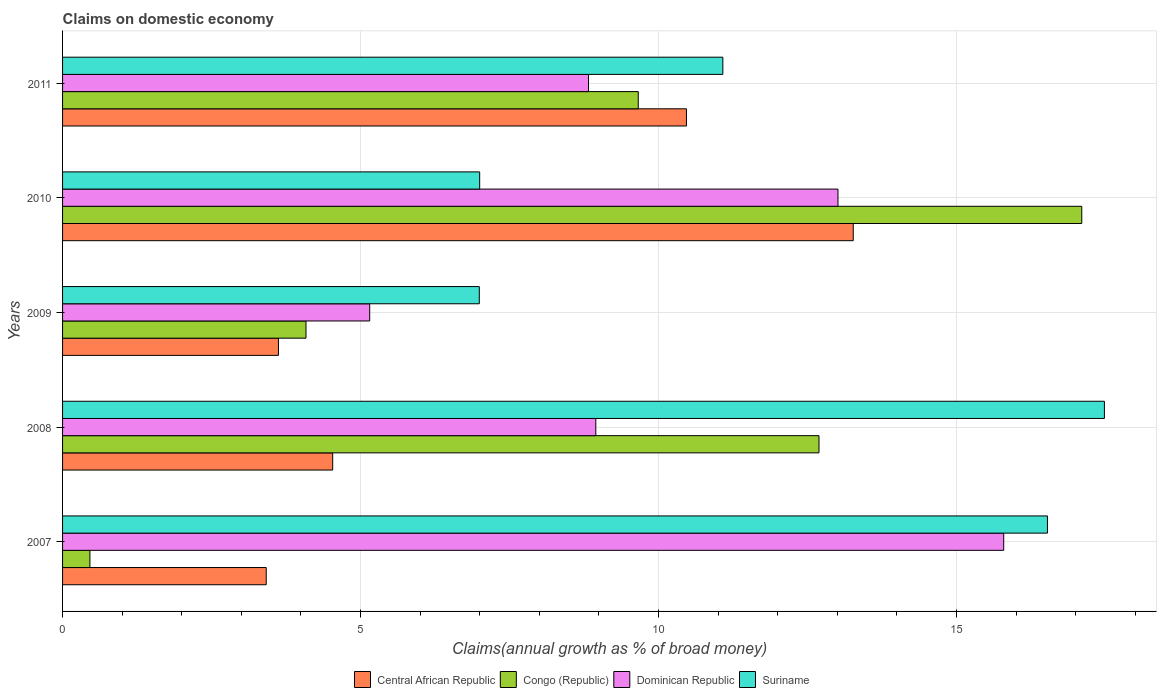How many groups of bars are there?
Offer a terse response. 5. What is the label of the 5th group of bars from the top?
Provide a short and direct response. 2007. What is the percentage of broad money claimed on domestic economy in Congo (Republic) in 2010?
Your answer should be compact. 17.1. Across all years, what is the maximum percentage of broad money claimed on domestic economy in Congo (Republic)?
Provide a succinct answer. 17.1. Across all years, what is the minimum percentage of broad money claimed on domestic economy in Congo (Republic)?
Provide a succinct answer. 0.46. In which year was the percentage of broad money claimed on domestic economy in Dominican Republic maximum?
Offer a very short reply. 2007. What is the total percentage of broad money claimed on domestic economy in Suriname in the graph?
Keep it short and to the point. 59.08. What is the difference between the percentage of broad money claimed on domestic economy in Central African Republic in 2007 and that in 2008?
Keep it short and to the point. -1.11. What is the difference between the percentage of broad money claimed on domestic economy in Suriname in 2009 and the percentage of broad money claimed on domestic economy in Dominican Republic in 2011?
Give a very brief answer. -1.83. What is the average percentage of broad money claimed on domestic economy in Congo (Republic) per year?
Keep it short and to the point. 8.8. In the year 2009, what is the difference between the percentage of broad money claimed on domestic economy in Central African Republic and percentage of broad money claimed on domestic economy in Suriname?
Offer a very short reply. -3.37. What is the ratio of the percentage of broad money claimed on domestic economy in Dominican Republic in 2008 to that in 2009?
Offer a very short reply. 1.74. Is the difference between the percentage of broad money claimed on domestic economy in Central African Republic in 2009 and 2010 greater than the difference between the percentage of broad money claimed on domestic economy in Suriname in 2009 and 2010?
Your answer should be compact. No. What is the difference between the highest and the second highest percentage of broad money claimed on domestic economy in Central African Republic?
Your answer should be very brief. 2.8. What is the difference between the highest and the lowest percentage of broad money claimed on domestic economy in Central African Republic?
Provide a short and direct response. 9.85. Is the sum of the percentage of broad money claimed on domestic economy in Congo (Republic) in 2007 and 2010 greater than the maximum percentage of broad money claimed on domestic economy in Suriname across all years?
Provide a short and direct response. Yes. Is it the case that in every year, the sum of the percentage of broad money claimed on domestic economy in Congo (Republic) and percentage of broad money claimed on domestic economy in Dominican Republic is greater than the sum of percentage of broad money claimed on domestic economy in Central African Republic and percentage of broad money claimed on domestic economy in Suriname?
Provide a succinct answer. No. What does the 2nd bar from the top in 2007 represents?
Your response must be concise. Dominican Republic. What does the 1st bar from the bottom in 2008 represents?
Offer a terse response. Central African Republic. Are all the bars in the graph horizontal?
Provide a short and direct response. Yes. How many years are there in the graph?
Your response must be concise. 5. What is the difference between two consecutive major ticks on the X-axis?
Make the answer very short. 5. Are the values on the major ticks of X-axis written in scientific E-notation?
Your answer should be compact. No. Does the graph contain grids?
Keep it short and to the point. Yes. How are the legend labels stacked?
Your response must be concise. Horizontal. What is the title of the graph?
Your answer should be compact. Claims on domestic economy. Does "Lao PDR" appear as one of the legend labels in the graph?
Ensure brevity in your answer.  No. What is the label or title of the X-axis?
Make the answer very short. Claims(annual growth as % of broad money). What is the label or title of the Y-axis?
Give a very brief answer. Years. What is the Claims(annual growth as % of broad money) of Central African Republic in 2007?
Provide a short and direct response. 3.42. What is the Claims(annual growth as % of broad money) in Congo (Republic) in 2007?
Keep it short and to the point. 0.46. What is the Claims(annual growth as % of broad money) of Dominican Republic in 2007?
Offer a terse response. 15.79. What is the Claims(annual growth as % of broad money) of Suriname in 2007?
Your response must be concise. 16.53. What is the Claims(annual growth as % of broad money) of Central African Republic in 2008?
Ensure brevity in your answer.  4.53. What is the Claims(annual growth as % of broad money) in Congo (Republic) in 2008?
Provide a short and direct response. 12.69. What is the Claims(annual growth as % of broad money) in Dominican Republic in 2008?
Make the answer very short. 8.95. What is the Claims(annual growth as % of broad money) in Suriname in 2008?
Offer a terse response. 17.48. What is the Claims(annual growth as % of broad money) of Central African Republic in 2009?
Ensure brevity in your answer.  3.62. What is the Claims(annual growth as % of broad money) of Congo (Republic) in 2009?
Offer a terse response. 4.08. What is the Claims(annual growth as % of broad money) of Dominican Republic in 2009?
Offer a very short reply. 5.15. What is the Claims(annual growth as % of broad money) in Suriname in 2009?
Your answer should be very brief. 6.99. What is the Claims(annual growth as % of broad money) of Central African Republic in 2010?
Offer a very short reply. 13.27. What is the Claims(annual growth as % of broad money) of Congo (Republic) in 2010?
Ensure brevity in your answer.  17.1. What is the Claims(annual growth as % of broad money) of Dominican Republic in 2010?
Provide a short and direct response. 13.01. What is the Claims(annual growth as % of broad money) of Suriname in 2010?
Ensure brevity in your answer.  7. What is the Claims(annual growth as % of broad money) in Central African Republic in 2011?
Make the answer very short. 10.47. What is the Claims(annual growth as % of broad money) of Congo (Republic) in 2011?
Offer a terse response. 9.66. What is the Claims(annual growth as % of broad money) in Dominican Republic in 2011?
Give a very brief answer. 8.83. What is the Claims(annual growth as % of broad money) in Suriname in 2011?
Ensure brevity in your answer.  11.08. Across all years, what is the maximum Claims(annual growth as % of broad money) in Central African Republic?
Provide a succinct answer. 13.27. Across all years, what is the maximum Claims(annual growth as % of broad money) of Congo (Republic)?
Give a very brief answer. 17.1. Across all years, what is the maximum Claims(annual growth as % of broad money) in Dominican Republic?
Your response must be concise. 15.79. Across all years, what is the maximum Claims(annual growth as % of broad money) of Suriname?
Provide a succinct answer. 17.48. Across all years, what is the minimum Claims(annual growth as % of broad money) of Central African Republic?
Your answer should be compact. 3.42. Across all years, what is the minimum Claims(annual growth as % of broad money) of Congo (Republic)?
Ensure brevity in your answer.  0.46. Across all years, what is the minimum Claims(annual growth as % of broad money) in Dominican Republic?
Provide a short and direct response. 5.15. Across all years, what is the minimum Claims(annual growth as % of broad money) in Suriname?
Keep it short and to the point. 6.99. What is the total Claims(annual growth as % of broad money) in Central African Republic in the graph?
Offer a very short reply. 35.31. What is the total Claims(annual growth as % of broad money) in Congo (Republic) in the graph?
Your answer should be very brief. 44. What is the total Claims(annual growth as % of broad money) of Dominican Republic in the graph?
Offer a very short reply. 51.73. What is the total Claims(annual growth as % of broad money) of Suriname in the graph?
Your response must be concise. 59.08. What is the difference between the Claims(annual growth as % of broad money) in Central African Republic in 2007 and that in 2008?
Ensure brevity in your answer.  -1.11. What is the difference between the Claims(annual growth as % of broad money) in Congo (Republic) in 2007 and that in 2008?
Your answer should be very brief. -12.23. What is the difference between the Claims(annual growth as % of broad money) of Dominican Republic in 2007 and that in 2008?
Ensure brevity in your answer.  6.84. What is the difference between the Claims(annual growth as % of broad money) of Suriname in 2007 and that in 2008?
Keep it short and to the point. -0.96. What is the difference between the Claims(annual growth as % of broad money) in Central African Republic in 2007 and that in 2009?
Your response must be concise. -0.21. What is the difference between the Claims(annual growth as % of broad money) of Congo (Republic) in 2007 and that in 2009?
Your response must be concise. -3.63. What is the difference between the Claims(annual growth as % of broad money) in Dominican Republic in 2007 and that in 2009?
Provide a succinct answer. 10.64. What is the difference between the Claims(annual growth as % of broad money) of Suriname in 2007 and that in 2009?
Make the answer very short. 9.53. What is the difference between the Claims(annual growth as % of broad money) in Central African Republic in 2007 and that in 2010?
Keep it short and to the point. -9.85. What is the difference between the Claims(annual growth as % of broad money) in Congo (Republic) in 2007 and that in 2010?
Your answer should be compact. -16.64. What is the difference between the Claims(annual growth as % of broad money) in Dominican Republic in 2007 and that in 2010?
Ensure brevity in your answer.  2.78. What is the difference between the Claims(annual growth as % of broad money) in Suriname in 2007 and that in 2010?
Keep it short and to the point. 9.53. What is the difference between the Claims(annual growth as % of broad money) of Central African Republic in 2007 and that in 2011?
Your answer should be compact. -7.05. What is the difference between the Claims(annual growth as % of broad money) in Congo (Republic) in 2007 and that in 2011?
Your response must be concise. -9.2. What is the difference between the Claims(annual growth as % of broad money) of Dominican Republic in 2007 and that in 2011?
Offer a terse response. 6.97. What is the difference between the Claims(annual growth as % of broad money) of Suriname in 2007 and that in 2011?
Provide a short and direct response. 5.45. What is the difference between the Claims(annual growth as % of broad money) of Central African Republic in 2008 and that in 2009?
Make the answer very short. 0.91. What is the difference between the Claims(annual growth as % of broad money) in Congo (Republic) in 2008 and that in 2009?
Provide a succinct answer. 8.61. What is the difference between the Claims(annual growth as % of broad money) in Dominican Republic in 2008 and that in 2009?
Offer a very short reply. 3.79. What is the difference between the Claims(annual growth as % of broad money) in Suriname in 2008 and that in 2009?
Provide a short and direct response. 10.49. What is the difference between the Claims(annual growth as % of broad money) of Central African Republic in 2008 and that in 2010?
Ensure brevity in your answer.  -8.73. What is the difference between the Claims(annual growth as % of broad money) of Congo (Republic) in 2008 and that in 2010?
Provide a short and direct response. -4.41. What is the difference between the Claims(annual growth as % of broad money) of Dominican Republic in 2008 and that in 2010?
Offer a terse response. -4.06. What is the difference between the Claims(annual growth as % of broad money) in Suriname in 2008 and that in 2010?
Provide a short and direct response. 10.48. What is the difference between the Claims(annual growth as % of broad money) of Central African Republic in 2008 and that in 2011?
Provide a short and direct response. -5.94. What is the difference between the Claims(annual growth as % of broad money) in Congo (Republic) in 2008 and that in 2011?
Your answer should be compact. 3.03. What is the difference between the Claims(annual growth as % of broad money) of Dominican Republic in 2008 and that in 2011?
Provide a succinct answer. 0.12. What is the difference between the Claims(annual growth as % of broad money) in Suriname in 2008 and that in 2011?
Your answer should be compact. 6.4. What is the difference between the Claims(annual growth as % of broad money) in Central African Republic in 2009 and that in 2010?
Provide a short and direct response. -9.64. What is the difference between the Claims(annual growth as % of broad money) in Congo (Republic) in 2009 and that in 2010?
Provide a succinct answer. -13.02. What is the difference between the Claims(annual growth as % of broad money) in Dominican Republic in 2009 and that in 2010?
Your answer should be compact. -7.86. What is the difference between the Claims(annual growth as % of broad money) of Suriname in 2009 and that in 2010?
Make the answer very short. -0.01. What is the difference between the Claims(annual growth as % of broad money) of Central African Republic in 2009 and that in 2011?
Offer a terse response. -6.85. What is the difference between the Claims(annual growth as % of broad money) of Congo (Republic) in 2009 and that in 2011?
Make the answer very short. -5.58. What is the difference between the Claims(annual growth as % of broad money) in Dominican Republic in 2009 and that in 2011?
Provide a succinct answer. -3.67. What is the difference between the Claims(annual growth as % of broad money) in Suriname in 2009 and that in 2011?
Make the answer very short. -4.09. What is the difference between the Claims(annual growth as % of broad money) of Central African Republic in 2010 and that in 2011?
Give a very brief answer. 2.8. What is the difference between the Claims(annual growth as % of broad money) of Congo (Republic) in 2010 and that in 2011?
Your response must be concise. 7.44. What is the difference between the Claims(annual growth as % of broad money) in Dominican Republic in 2010 and that in 2011?
Your response must be concise. 4.19. What is the difference between the Claims(annual growth as % of broad money) of Suriname in 2010 and that in 2011?
Make the answer very short. -4.08. What is the difference between the Claims(annual growth as % of broad money) of Central African Republic in 2007 and the Claims(annual growth as % of broad money) of Congo (Republic) in 2008?
Your answer should be very brief. -9.28. What is the difference between the Claims(annual growth as % of broad money) of Central African Republic in 2007 and the Claims(annual growth as % of broad money) of Dominican Republic in 2008?
Your answer should be very brief. -5.53. What is the difference between the Claims(annual growth as % of broad money) in Central African Republic in 2007 and the Claims(annual growth as % of broad money) in Suriname in 2008?
Give a very brief answer. -14.06. What is the difference between the Claims(annual growth as % of broad money) in Congo (Republic) in 2007 and the Claims(annual growth as % of broad money) in Dominican Republic in 2008?
Provide a short and direct response. -8.49. What is the difference between the Claims(annual growth as % of broad money) in Congo (Republic) in 2007 and the Claims(annual growth as % of broad money) in Suriname in 2008?
Your answer should be compact. -17.02. What is the difference between the Claims(annual growth as % of broad money) in Dominican Republic in 2007 and the Claims(annual growth as % of broad money) in Suriname in 2008?
Make the answer very short. -1.69. What is the difference between the Claims(annual growth as % of broad money) in Central African Republic in 2007 and the Claims(annual growth as % of broad money) in Congo (Republic) in 2009?
Provide a short and direct response. -0.67. What is the difference between the Claims(annual growth as % of broad money) of Central African Republic in 2007 and the Claims(annual growth as % of broad money) of Dominican Republic in 2009?
Your response must be concise. -1.74. What is the difference between the Claims(annual growth as % of broad money) of Central African Republic in 2007 and the Claims(annual growth as % of broad money) of Suriname in 2009?
Your answer should be compact. -3.57. What is the difference between the Claims(annual growth as % of broad money) in Congo (Republic) in 2007 and the Claims(annual growth as % of broad money) in Dominican Republic in 2009?
Give a very brief answer. -4.69. What is the difference between the Claims(annual growth as % of broad money) of Congo (Republic) in 2007 and the Claims(annual growth as % of broad money) of Suriname in 2009?
Offer a terse response. -6.53. What is the difference between the Claims(annual growth as % of broad money) in Dominican Republic in 2007 and the Claims(annual growth as % of broad money) in Suriname in 2009?
Provide a short and direct response. 8.8. What is the difference between the Claims(annual growth as % of broad money) of Central African Republic in 2007 and the Claims(annual growth as % of broad money) of Congo (Republic) in 2010?
Offer a very short reply. -13.68. What is the difference between the Claims(annual growth as % of broad money) of Central African Republic in 2007 and the Claims(annual growth as % of broad money) of Dominican Republic in 2010?
Your answer should be very brief. -9.59. What is the difference between the Claims(annual growth as % of broad money) of Central African Republic in 2007 and the Claims(annual growth as % of broad money) of Suriname in 2010?
Your answer should be compact. -3.58. What is the difference between the Claims(annual growth as % of broad money) in Congo (Republic) in 2007 and the Claims(annual growth as % of broad money) in Dominican Republic in 2010?
Keep it short and to the point. -12.55. What is the difference between the Claims(annual growth as % of broad money) of Congo (Republic) in 2007 and the Claims(annual growth as % of broad money) of Suriname in 2010?
Ensure brevity in your answer.  -6.54. What is the difference between the Claims(annual growth as % of broad money) in Dominican Republic in 2007 and the Claims(annual growth as % of broad money) in Suriname in 2010?
Offer a very short reply. 8.79. What is the difference between the Claims(annual growth as % of broad money) in Central African Republic in 2007 and the Claims(annual growth as % of broad money) in Congo (Republic) in 2011?
Provide a short and direct response. -6.24. What is the difference between the Claims(annual growth as % of broad money) in Central African Republic in 2007 and the Claims(annual growth as % of broad money) in Dominican Republic in 2011?
Your answer should be compact. -5.41. What is the difference between the Claims(annual growth as % of broad money) of Central African Republic in 2007 and the Claims(annual growth as % of broad money) of Suriname in 2011?
Your answer should be very brief. -7.66. What is the difference between the Claims(annual growth as % of broad money) in Congo (Republic) in 2007 and the Claims(annual growth as % of broad money) in Dominican Republic in 2011?
Make the answer very short. -8.37. What is the difference between the Claims(annual growth as % of broad money) in Congo (Republic) in 2007 and the Claims(annual growth as % of broad money) in Suriname in 2011?
Offer a terse response. -10.62. What is the difference between the Claims(annual growth as % of broad money) in Dominican Republic in 2007 and the Claims(annual growth as % of broad money) in Suriname in 2011?
Give a very brief answer. 4.71. What is the difference between the Claims(annual growth as % of broad money) of Central African Republic in 2008 and the Claims(annual growth as % of broad money) of Congo (Republic) in 2009?
Offer a very short reply. 0.45. What is the difference between the Claims(annual growth as % of broad money) of Central African Republic in 2008 and the Claims(annual growth as % of broad money) of Dominican Republic in 2009?
Keep it short and to the point. -0.62. What is the difference between the Claims(annual growth as % of broad money) in Central African Republic in 2008 and the Claims(annual growth as % of broad money) in Suriname in 2009?
Your response must be concise. -2.46. What is the difference between the Claims(annual growth as % of broad money) in Congo (Republic) in 2008 and the Claims(annual growth as % of broad money) in Dominican Republic in 2009?
Offer a very short reply. 7.54. What is the difference between the Claims(annual growth as % of broad money) in Congo (Republic) in 2008 and the Claims(annual growth as % of broad money) in Suriname in 2009?
Your answer should be compact. 5.7. What is the difference between the Claims(annual growth as % of broad money) in Dominican Republic in 2008 and the Claims(annual growth as % of broad money) in Suriname in 2009?
Offer a terse response. 1.96. What is the difference between the Claims(annual growth as % of broad money) of Central African Republic in 2008 and the Claims(annual growth as % of broad money) of Congo (Republic) in 2010?
Offer a very short reply. -12.57. What is the difference between the Claims(annual growth as % of broad money) of Central African Republic in 2008 and the Claims(annual growth as % of broad money) of Dominican Republic in 2010?
Keep it short and to the point. -8.48. What is the difference between the Claims(annual growth as % of broad money) of Central African Republic in 2008 and the Claims(annual growth as % of broad money) of Suriname in 2010?
Offer a terse response. -2.47. What is the difference between the Claims(annual growth as % of broad money) in Congo (Republic) in 2008 and the Claims(annual growth as % of broad money) in Dominican Republic in 2010?
Your answer should be very brief. -0.32. What is the difference between the Claims(annual growth as % of broad money) in Congo (Republic) in 2008 and the Claims(annual growth as % of broad money) in Suriname in 2010?
Offer a terse response. 5.69. What is the difference between the Claims(annual growth as % of broad money) in Dominican Republic in 2008 and the Claims(annual growth as % of broad money) in Suriname in 2010?
Provide a short and direct response. 1.95. What is the difference between the Claims(annual growth as % of broad money) of Central African Republic in 2008 and the Claims(annual growth as % of broad money) of Congo (Republic) in 2011?
Provide a short and direct response. -5.13. What is the difference between the Claims(annual growth as % of broad money) of Central African Republic in 2008 and the Claims(annual growth as % of broad money) of Dominican Republic in 2011?
Ensure brevity in your answer.  -4.29. What is the difference between the Claims(annual growth as % of broad money) of Central African Republic in 2008 and the Claims(annual growth as % of broad money) of Suriname in 2011?
Your answer should be very brief. -6.55. What is the difference between the Claims(annual growth as % of broad money) of Congo (Republic) in 2008 and the Claims(annual growth as % of broad money) of Dominican Republic in 2011?
Keep it short and to the point. 3.87. What is the difference between the Claims(annual growth as % of broad money) of Congo (Republic) in 2008 and the Claims(annual growth as % of broad money) of Suriname in 2011?
Give a very brief answer. 1.61. What is the difference between the Claims(annual growth as % of broad money) of Dominican Republic in 2008 and the Claims(annual growth as % of broad money) of Suriname in 2011?
Give a very brief answer. -2.13. What is the difference between the Claims(annual growth as % of broad money) in Central African Republic in 2009 and the Claims(annual growth as % of broad money) in Congo (Republic) in 2010?
Keep it short and to the point. -13.48. What is the difference between the Claims(annual growth as % of broad money) in Central African Republic in 2009 and the Claims(annual growth as % of broad money) in Dominican Republic in 2010?
Your answer should be very brief. -9.39. What is the difference between the Claims(annual growth as % of broad money) in Central African Republic in 2009 and the Claims(annual growth as % of broad money) in Suriname in 2010?
Make the answer very short. -3.38. What is the difference between the Claims(annual growth as % of broad money) of Congo (Republic) in 2009 and the Claims(annual growth as % of broad money) of Dominican Republic in 2010?
Give a very brief answer. -8.93. What is the difference between the Claims(annual growth as % of broad money) in Congo (Republic) in 2009 and the Claims(annual growth as % of broad money) in Suriname in 2010?
Give a very brief answer. -2.91. What is the difference between the Claims(annual growth as % of broad money) in Dominican Republic in 2009 and the Claims(annual growth as % of broad money) in Suriname in 2010?
Your response must be concise. -1.85. What is the difference between the Claims(annual growth as % of broad money) of Central African Republic in 2009 and the Claims(annual growth as % of broad money) of Congo (Republic) in 2011?
Make the answer very short. -6.04. What is the difference between the Claims(annual growth as % of broad money) in Central African Republic in 2009 and the Claims(annual growth as % of broad money) in Dominican Republic in 2011?
Ensure brevity in your answer.  -5.2. What is the difference between the Claims(annual growth as % of broad money) of Central African Republic in 2009 and the Claims(annual growth as % of broad money) of Suriname in 2011?
Provide a succinct answer. -7.46. What is the difference between the Claims(annual growth as % of broad money) in Congo (Republic) in 2009 and the Claims(annual growth as % of broad money) in Dominican Republic in 2011?
Make the answer very short. -4.74. What is the difference between the Claims(annual growth as % of broad money) of Congo (Republic) in 2009 and the Claims(annual growth as % of broad money) of Suriname in 2011?
Offer a very short reply. -6.99. What is the difference between the Claims(annual growth as % of broad money) in Dominican Republic in 2009 and the Claims(annual growth as % of broad money) in Suriname in 2011?
Keep it short and to the point. -5.93. What is the difference between the Claims(annual growth as % of broad money) of Central African Republic in 2010 and the Claims(annual growth as % of broad money) of Congo (Republic) in 2011?
Your answer should be compact. 3.61. What is the difference between the Claims(annual growth as % of broad money) in Central African Republic in 2010 and the Claims(annual growth as % of broad money) in Dominican Republic in 2011?
Your response must be concise. 4.44. What is the difference between the Claims(annual growth as % of broad money) in Central African Republic in 2010 and the Claims(annual growth as % of broad money) in Suriname in 2011?
Provide a short and direct response. 2.19. What is the difference between the Claims(annual growth as % of broad money) of Congo (Republic) in 2010 and the Claims(annual growth as % of broad money) of Dominican Republic in 2011?
Make the answer very short. 8.28. What is the difference between the Claims(annual growth as % of broad money) in Congo (Republic) in 2010 and the Claims(annual growth as % of broad money) in Suriname in 2011?
Keep it short and to the point. 6.02. What is the difference between the Claims(annual growth as % of broad money) of Dominican Republic in 2010 and the Claims(annual growth as % of broad money) of Suriname in 2011?
Give a very brief answer. 1.93. What is the average Claims(annual growth as % of broad money) of Central African Republic per year?
Keep it short and to the point. 7.06. What is the average Claims(annual growth as % of broad money) of Congo (Republic) per year?
Offer a terse response. 8.8. What is the average Claims(annual growth as % of broad money) of Dominican Republic per year?
Keep it short and to the point. 10.35. What is the average Claims(annual growth as % of broad money) in Suriname per year?
Your answer should be very brief. 11.82. In the year 2007, what is the difference between the Claims(annual growth as % of broad money) in Central African Republic and Claims(annual growth as % of broad money) in Congo (Republic)?
Your answer should be compact. 2.96. In the year 2007, what is the difference between the Claims(annual growth as % of broad money) of Central African Republic and Claims(annual growth as % of broad money) of Dominican Republic?
Ensure brevity in your answer.  -12.37. In the year 2007, what is the difference between the Claims(annual growth as % of broad money) of Central African Republic and Claims(annual growth as % of broad money) of Suriname?
Ensure brevity in your answer.  -13.11. In the year 2007, what is the difference between the Claims(annual growth as % of broad money) of Congo (Republic) and Claims(annual growth as % of broad money) of Dominican Republic?
Offer a very short reply. -15.33. In the year 2007, what is the difference between the Claims(annual growth as % of broad money) of Congo (Republic) and Claims(annual growth as % of broad money) of Suriname?
Your response must be concise. -16.07. In the year 2007, what is the difference between the Claims(annual growth as % of broad money) of Dominican Republic and Claims(annual growth as % of broad money) of Suriname?
Give a very brief answer. -0.73. In the year 2008, what is the difference between the Claims(annual growth as % of broad money) of Central African Republic and Claims(annual growth as % of broad money) of Congo (Republic)?
Offer a very short reply. -8.16. In the year 2008, what is the difference between the Claims(annual growth as % of broad money) in Central African Republic and Claims(annual growth as % of broad money) in Dominican Republic?
Ensure brevity in your answer.  -4.42. In the year 2008, what is the difference between the Claims(annual growth as % of broad money) in Central African Republic and Claims(annual growth as % of broad money) in Suriname?
Your answer should be compact. -12.95. In the year 2008, what is the difference between the Claims(annual growth as % of broad money) of Congo (Republic) and Claims(annual growth as % of broad money) of Dominican Republic?
Your response must be concise. 3.74. In the year 2008, what is the difference between the Claims(annual growth as % of broad money) of Congo (Republic) and Claims(annual growth as % of broad money) of Suriname?
Make the answer very short. -4.79. In the year 2008, what is the difference between the Claims(annual growth as % of broad money) of Dominican Republic and Claims(annual growth as % of broad money) of Suriname?
Make the answer very short. -8.53. In the year 2009, what is the difference between the Claims(annual growth as % of broad money) of Central African Republic and Claims(annual growth as % of broad money) of Congo (Republic)?
Offer a very short reply. -0.46. In the year 2009, what is the difference between the Claims(annual growth as % of broad money) in Central African Republic and Claims(annual growth as % of broad money) in Dominican Republic?
Ensure brevity in your answer.  -1.53. In the year 2009, what is the difference between the Claims(annual growth as % of broad money) of Central African Republic and Claims(annual growth as % of broad money) of Suriname?
Provide a short and direct response. -3.37. In the year 2009, what is the difference between the Claims(annual growth as % of broad money) in Congo (Republic) and Claims(annual growth as % of broad money) in Dominican Republic?
Keep it short and to the point. -1.07. In the year 2009, what is the difference between the Claims(annual growth as % of broad money) of Congo (Republic) and Claims(annual growth as % of broad money) of Suriname?
Offer a very short reply. -2.91. In the year 2009, what is the difference between the Claims(annual growth as % of broad money) in Dominican Republic and Claims(annual growth as % of broad money) in Suriname?
Your answer should be compact. -1.84. In the year 2010, what is the difference between the Claims(annual growth as % of broad money) in Central African Republic and Claims(annual growth as % of broad money) in Congo (Republic)?
Provide a succinct answer. -3.83. In the year 2010, what is the difference between the Claims(annual growth as % of broad money) in Central African Republic and Claims(annual growth as % of broad money) in Dominican Republic?
Your answer should be compact. 0.26. In the year 2010, what is the difference between the Claims(annual growth as % of broad money) of Central African Republic and Claims(annual growth as % of broad money) of Suriname?
Offer a terse response. 6.27. In the year 2010, what is the difference between the Claims(annual growth as % of broad money) in Congo (Republic) and Claims(annual growth as % of broad money) in Dominican Republic?
Give a very brief answer. 4.09. In the year 2010, what is the difference between the Claims(annual growth as % of broad money) in Congo (Republic) and Claims(annual growth as % of broad money) in Suriname?
Provide a succinct answer. 10.1. In the year 2010, what is the difference between the Claims(annual growth as % of broad money) of Dominican Republic and Claims(annual growth as % of broad money) of Suriname?
Ensure brevity in your answer.  6.01. In the year 2011, what is the difference between the Claims(annual growth as % of broad money) in Central African Republic and Claims(annual growth as % of broad money) in Congo (Republic)?
Ensure brevity in your answer.  0.81. In the year 2011, what is the difference between the Claims(annual growth as % of broad money) in Central African Republic and Claims(annual growth as % of broad money) in Dominican Republic?
Provide a short and direct response. 1.64. In the year 2011, what is the difference between the Claims(annual growth as % of broad money) in Central African Republic and Claims(annual growth as % of broad money) in Suriname?
Offer a terse response. -0.61. In the year 2011, what is the difference between the Claims(annual growth as % of broad money) in Congo (Republic) and Claims(annual growth as % of broad money) in Dominican Republic?
Provide a short and direct response. 0.83. In the year 2011, what is the difference between the Claims(annual growth as % of broad money) of Congo (Republic) and Claims(annual growth as % of broad money) of Suriname?
Make the answer very short. -1.42. In the year 2011, what is the difference between the Claims(annual growth as % of broad money) in Dominican Republic and Claims(annual growth as % of broad money) in Suriname?
Provide a short and direct response. -2.25. What is the ratio of the Claims(annual growth as % of broad money) in Central African Republic in 2007 to that in 2008?
Your answer should be compact. 0.75. What is the ratio of the Claims(annual growth as % of broad money) in Congo (Republic) in 2007 to that in 2008?
Your answer should be very brief. 0.04. What is the ratio of the Claims(annual growth as % of broad money) of Dominican Republic in 2007 to that in 2008?
Make the answer very short. 1.76. What is the ratio of the Claims(annual growth as % of broad money) in Suriname in 2007 to that in 2008?
Provide a succinct answer. 0.95. What is the ratio of the Claims(annual growth as % of broad money) of Central African Republic in 2007 to that in 2009?
Ensure brevity in your answer.  0.94. What is the ratio of the Claims(annual growth as % of broad money) in Congo (Republic) in 2007 to that in 2009?
Keep it short and to the point. 0.11. What is the ratio of the Claims(annual growth as % of broad money) in Dominican Republic in 2007 to that in 2009?
Provide a short and direct response. 3.06. What is the ratio of the Claims(annual growth as % of broad money) of Suriname in 2007 to that in 2009?
Offer a terse response. 2.36. What is the ratio of the Claims(annual growth as % of broad money) in Central African Republic in 2007 to that in 2010?
Your answer should be very brief. 0.26. What is the ratio of the Claims(annual growth as % of broad money) of Congo (Republic) in 2007 to that in 2010?
Your answer should be compact. 0.03. What is the ratio of the Claims(annual growth as % of broad money) in Dominican Republic in 2007 to that in 2010?
Provide a short and direct response. 1.21. What is the ratio of the Claims(annual growth as % of broad money) in Suriname in 2007 to that in 2010?
Your answer should be very brief. 2.36. What is the ratio of the Claims(annual growth as % of broad money) in Central African Republic in 2007 to that in 2011?
Offer a terse response. 0.33. What is the ratio of the Claims(annual growth as % of broad money) in Congo (Republic) in 2007 to that in 2011?
Your answer should be compact. 0.05. What is the ratio of the Claims(annual growth as % of broad money) in Dominican Republic in 2007 to that in 2011?
Keep it short and to the point. 1.79. What is the ratio of the Claims(annual growth as % of broad money) of Suriname in 2007 to that in 2011?
Provide a succinct answer. 1.49. What is the ratio of the Claims(annual growth as % of broad money) in Central African Republic in 2008 to that in 2009?
Offer a terse response. 1.25. What is the ratio of the Claims(annual growth as % of broad money) in Congo (Republic) in 2008 to that in 2009?
Make the answer very short. 3.11. What is the ratio of the Claims(annual growth as % of broad money) of Dominican Republic in 2008 to that in 2009?
Give a very brief answer. 1.74. What is the ratio of the Claims(annual growth as % of broad money) of Suriname in 2008 to that in 2009?
Provide a short and direct response. 2.5. What is the ratio of the Claims(annual growth as % of broad money) of Central African Republic in 2008 to that in 2010?
Ensure brevity in your answer.  0.34. What is the ratio of the Claims(annual growth as % of broad money) of Congo (Republic) in 2008 to that in 2010?
Offer a very short reply. 0.74. What is the ratio of the Claims(annual growth as % of broad money) of Dominican Republic in 2008 to that in 2010?
Ensure brevity in your answer.  0.69. What is the ratio of the Claims(annual growth as % of broad money) in Suriname in 2008 to that in 2010?
Provide a short and direct response. 2.5. What is the ratio of the Claims(annual growth as % of broad money) of Central African Republic in 2008 to that in 2011?
Give a very brief answer. 0.43. What is the ratio of the Claims(annual growth as % of broad money) in Congo (Republic) in 2008 to that in 2011?
Provide a succinct answer. 1.31. What is the ratio of the Claims(annual growth as % of broad money) in Dominican Republic in 2008 to that in 2011?
Your response must be concise. 1.01. What is the ratio of the Claims(annual growth as % of broad money) in Suriname in 2008 to that in 2011?
Keep it short and to the point. 1.58. What is the ratio of the Claims(annual growth as % of broad money) of Central African Republic in 2009 to that in 2010?
Your answer should be very brief. 0.27. What is the ratio of the Claims(annual growth as % of broad money) of Congo (Republic) in 2009 to that in 2010?
Your answer should be compact. 0.24. What is the ratio of the Claims(annual growth as % of broad money) of Dominican Republic in 2009 to that in 2010?
Make the answer very short. 0.4. What is the ratio of the Claims(annual growth as % of broad money) of Suriname in 2009 to that in 2010?
Provide a succinct answer. 1. What is the ratio of the Claims(annual growth as % of broad money) of Central African Republic in 2009 to that in 2011?
Provide a short and direct response. 0.35. What is the ratio of the Claims(annual growth as % of broad money) of Congo (Republic) in 2009 to that in 2011?
Make the answer very short. 0.42. What is the ratio of the Claims(annual growth as % of broad money) of Dominican Republic in 2009 to that in 2011?
Provide a succinct answer. 0.58. What is the ratio of the Claims(annual growth as % of broad money) of Suriname in 2009 to that in 2011?
Your answer should be compact. 0.63. What is the ratio of the Claims(annual growth as % of broad money) of Central African Republic in 2010 to that in 2011?
Give a very brief answer. 1.27. What is the ratio of the Claims(annual growth as % of broad money) in Congo (Republic) in 2010 to that in 2011?
Give a very brief answer. 1.77. What is the ratio of the Claims(annual growth as % of broad money) in Dominican Republic in 2010 to that in 2011?
Ensure brevity in your answer.  1.47. What is the ratio of the Claims(annual growth as % of broad money) in Suriname in 2010 to that in 2011?
Your response must be concise. 0.63. What is the difference between the highest and the second highest Claims(annual growth as % of broad money) in Central African Republic?
Provide a short and direct response. 2.8. What is the difference between the highest and the second highest Claims(annual growth as % of broad money) in Congo (Republic)?
Your answer should be very brief. 4.41. What is the difference between the highest and the second highest Claims(annual growth as % of broad money) in Dominican Republic?
Keep it short and to the point. 2.78. What is the difference between the highest and the second highest Claims(annual growth as % of broad money) of Suriname?
Make the answer very short. 0.96. What is the difference between the highest and the lowest Claims(annual growth as % of broad money) of Central African Republic?
Ensure brevity in your answer.  9.85. What is the difference between the highest and the lowest Claims(annual growth as % of broad money) of Congo (Republic)?
Keep it short and to the point. 16.64. What is the difference between the highest and the lowest Claims(annual growth as % of broad money) in Dominican Republic?
Your answer should be very brief. 10.64. What is the difference between the highest and the lowest Claims(annual growth as % of broad money) of Suriname?
Make the answer very short. 10.49. 